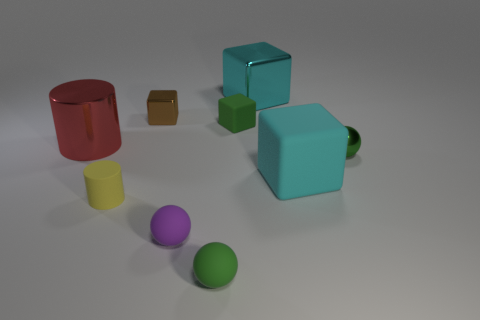Add 1 red shiny objects. How many objects exist? 10 Subtract all blocks. How many objects are left? 5 Add 5 tiny metal balls. How many tiny metal balls are left? 6 Add 3 tiny brown shiny blocks. How many tiny brown shiny blocks exist? 4 Subtract 0 gray balls. How many objects are left? 9 Subtract all tiny metal cubes. Subtract all tiny matte things. How many objects are left? 4 